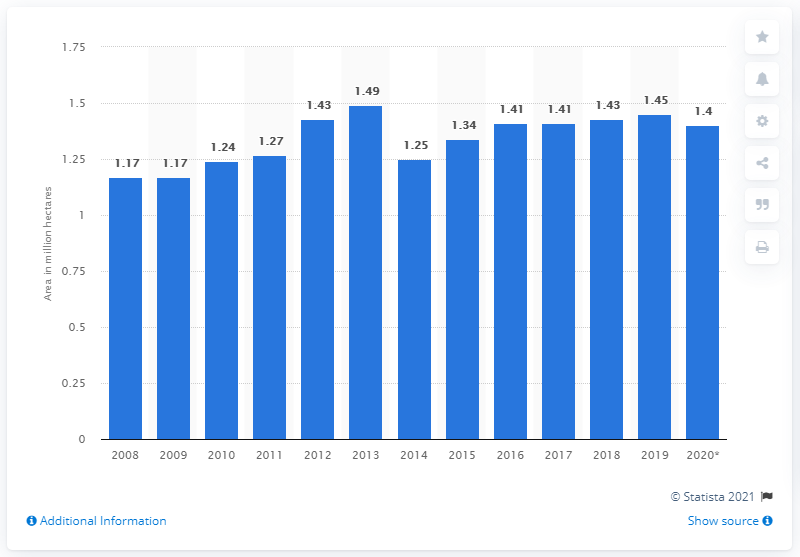Specify some key components in this picture. In 2019, Canada harvested approximately 1.45 million hectares of land dedicated to producing corn for grain. In the previous year, Canada harvested approximately 1.43 million hectares of corn for grain. 